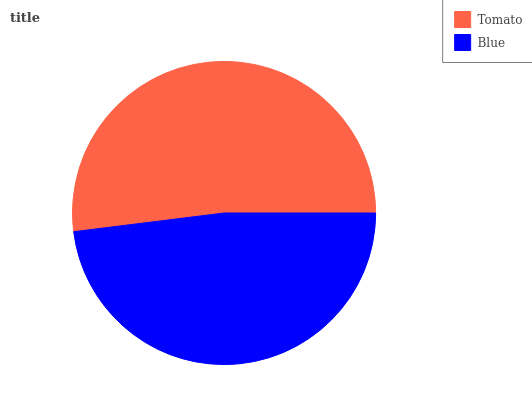Is Blue the minimum?
Answer yes or no. Yes. Is Tomato the maximum?
Answer yes or no. Yes. Is Blue the maximum?
Answer yes or no. No. Is Tomato greater than Blue?
Answer yes or no. Yes. Is Blue less than Tomato?
Answer yes or no. Yes. Is Blue greater than Tomato?
Answer yes or no. No. Is Tomato less than Blue?
Answer yes or no. No. Is Tomato the high median?
Answer yes or no. Yes. Is Blue the low median?
Answer yes or no. Yes. Is Blue the high median?
Answer yes or no. No. Is Tomato the low median?
Answer yes or no. No. 